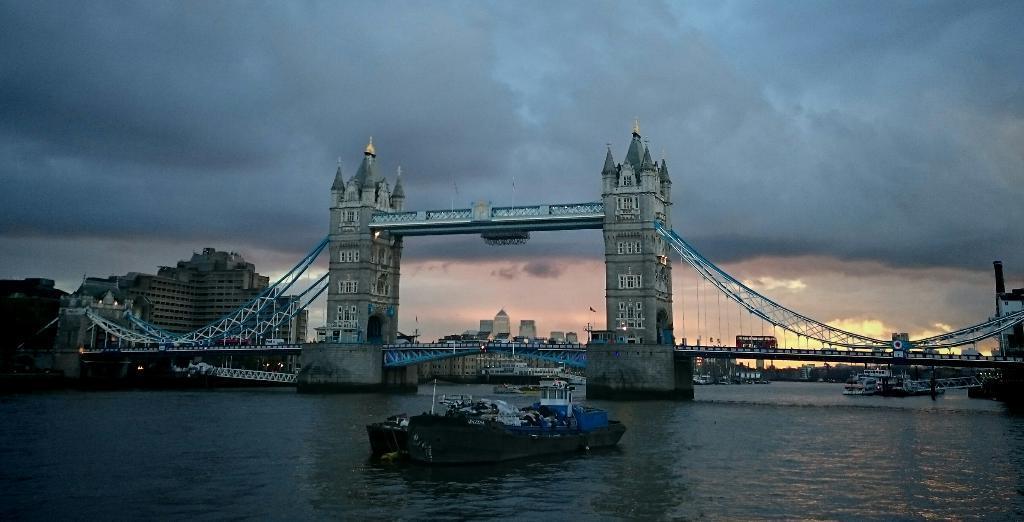Can you describe this image briefly? In this picture I can observe a bridge over the river. There are some vehicles moving on the bridge. I can observe a boat floating on the water. In the background there are buildings and a sky with some clouds. 